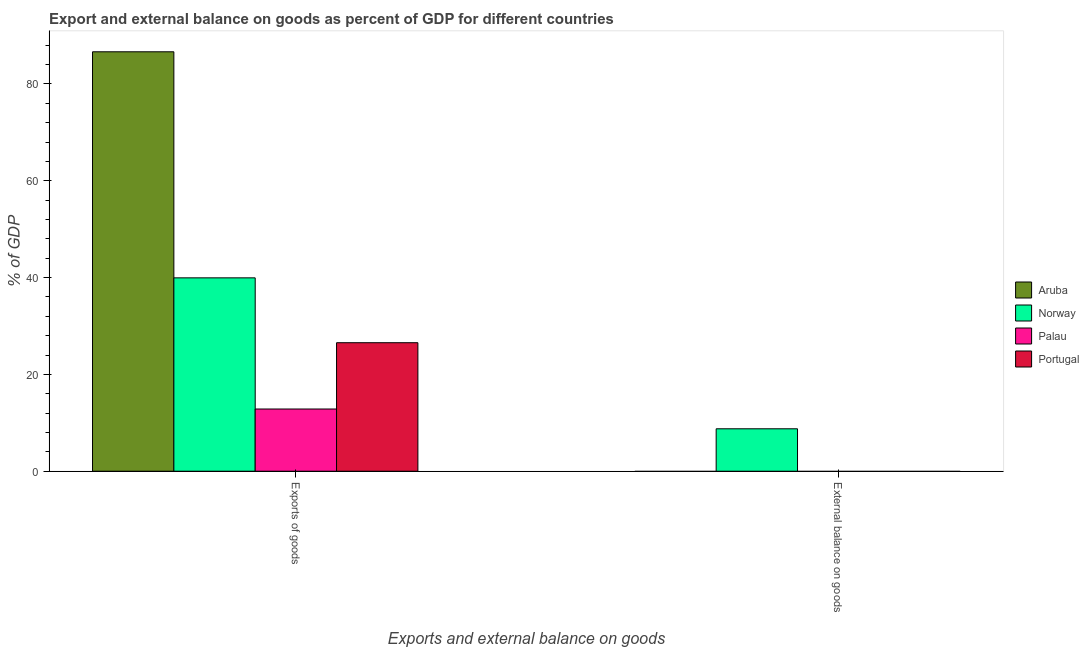How many different coloured bars are there?
Offer a very short reply. 4. Are the number of bars on each tick of the X-axis equal?
Provide a short and direct response. No. How many bars are there on the 2nd tick from the left?
Keep it short and to the point. 1. How many bars are there on the 1st tick from the right?
Give a very brief answer. 1. What is the label of the 1st group of bars from the left?
Ensure brevity in your answer.  Exports of goods. What is the export of goods as percentage of gdp in Aruba?
Provide a short and direct response. 86.64. Across all countries, what is the maximum external balance on goods as percentage of gdp?
Make the answer very short. 8.76. Across all countries, what is the minimum export of goods as percentage of gdp?
Your answer should be compact. 12.85. In which country was the external balance on goods as percentage of gdp maximum?
Give a very brief answer. Norway. What is the total export of goods as percentage of gdp in the graph?
Give a very brief answer. 165.98. What is the difference between the export of goods as percentage of gdp in Norway and that in Portugal?
Offer a terse response. 13.4. What is the difference between the export of goods as percentage of gdp in Portugal and the external balance on goods as percentage of gdp in Aruba?
Give a very brief answer. 26.55. What is the average export of goods as percentage of gdp per country?
Make the answer very short. 41.5. What is the difference between the export of goods as percentage of gdp and external balance on goods as percentage of gdp in Norway?
Your answer should be very brief. 31.18. What is the ratio of the export of goods as percentage of gdp in Norway to that in Aruba?
Your response must be concise. 0.46. Is the export of goods as percentage of gdp in Aruba less than that in Palau?
Your response must be concise. No. In how many countries, is the export of goods as percentage of gdp greater than the average export of goods as percentage of gdp taken over all countries?
Provide a succinct answer. 1. How many bars are there?
Ensure brevity in your answer.  5. How many countries are there in the graph?
Provide a short and direct response. 4. Are the values on the major ticks of Y-axis written in scientific E-notation?
Provide a succinct answer. No. Does the graph contain grids?
Your response must be concise. No. How many legend labels are there?
Offer a terse response. 4. How are the legend labels stacked?
Offer a terse response. Vertical. What is the title of the graph?
Offer a very short reply. Export and external balance on goods as percent of GDP for different countries. What is the label or title of the X-axis?
Your answer should be very brief. Exports and external balance on goods. What is the label or title of the Y-axis?
Provide a short and direct response. % of GDP. What is the % of GDP of Aruba in Exports of goods?
Provide a short and direct response. 86.64. What is the % of GDP in Norway in Exports of goods?
Your response must be concise. 39.94. What is the % of GDP of Palau in Exports of goods?
Provide a succinct answer. 12.85. What is the % of GDP of Portugal in Exports of goods?
Your answer should be very brief. 26.55. What is the % of GDP in Norway in External balance on goods?
Your answer should be very brief. 8.76. What is the % of GDP of Palau in External balance on goods?
Make the answer very short. 0. Across all Exports and external balance on goods, what is the maximum % of GDP of Aruba?
Provide a short and direct response. 86.64. Across all Exports and external balance on goods, what is the maximum % of GDP of Norway?
Your response must be concise. 39.94. Across all Exports and external balance on goods, what is the maximum % of GDP in Palau?
Offer a very short reply. 12.85. Across all Exports and external balance on goods, what is the maximum % of GDP in Portugal?
Offer a very short reply. 26.55. Across all Exports and external balance on goods, what is the minimum % of GDP in Norway?
Provide a succinct answer. 8.76. Across all Exports and external balance on goods, what is the minimum % of GDP in Palau?
Provide a short and direct response. 0. Across all Exports and external balance on goods, what is the minimum % of GDP of Portugal?
Ensure brevity in your answer.  0. What is the total % of GDP of Aruba in the graph?
Ensure brevity in your answer.  86.64. What is the total % of GDP of Norway in the graph?
Ensure brevity in your answer.  48.71. What is the total % of GDP in Palau in the graph?
Give a very brief answer. 12.85. What is the total % of GDP in Portugal in the graph?
Offer a terse response. 26.55. What is the difference between the % of GDP in Norway in Exports of goods and that in External balance on goods?
Offer a very short reply. 31.18. What is the difference between the % of GDP of Aruba in Exports of goods and the % of GDP of Norway in External balance on goods?
Offer a terse response. 77.88. What is the average % of GDP of Aruba per Exports and external balance on goods?
Offer a terse response. 43.32. What is the average % of GDP of Norway per Exports and external balance on goods?
Your answer should be compact. 24.35. What is the average % of GDP of Palau per Exports and external balance on goods?
Offer a very short reply. 6.43. What is the average % of GDP in Portugal per Exports and external balance on goods?
Provide a succinct answer. 13.27. What is the difference between the % of GDP of Aruba and % of GDP of Norway in Exports of goods?
Offer a very short reply. 46.7. What is the difference between the % of GDP of Aruba and % of GDP of Palau in Exports of goods?
Give a very brief answer. 73.79. What is the difference between the % of GDP of Aruba and % of GDP of Portugal in Exports of goods?
Offer a very short reply. 60.09. What is the difference between the % of GDP in Norway and % of GDP in Palau in Exports of goods?
Your response must be concise. 27.09. What is the difference between the % of GDP in Norway and % of GDP in Portugal in Exports of goods?
Ensure brevity in your answer.  13.4. What is the difference between the % of GDP in Palau and % of GDP in Portugal in Exports of goods?
Your answer should be very brief. -13.69. What is the ratio of the % of GDP in Norway in Exports of goods to that in External balance on goods?
Your answer should be compact. 4.56. What is the difference between the highest and the second highest % of GDP of Norway?
Provide a short and direct response. 31.18. What is the difference between the highest and the lowest % of GDP of Aruba?
Offer a terse response. 86.64. What is the difference between the highest and the lowest % of GDP in Norway?
Your answer should be compact. 31.18. What is the difference between the highest and the lowest % of GDP of Palau?
Your answer should be very brief. 12.85. What is the difference between the highest and the lowest % of GDP of Portugal?
Your answer should be very brief. 26.55. 